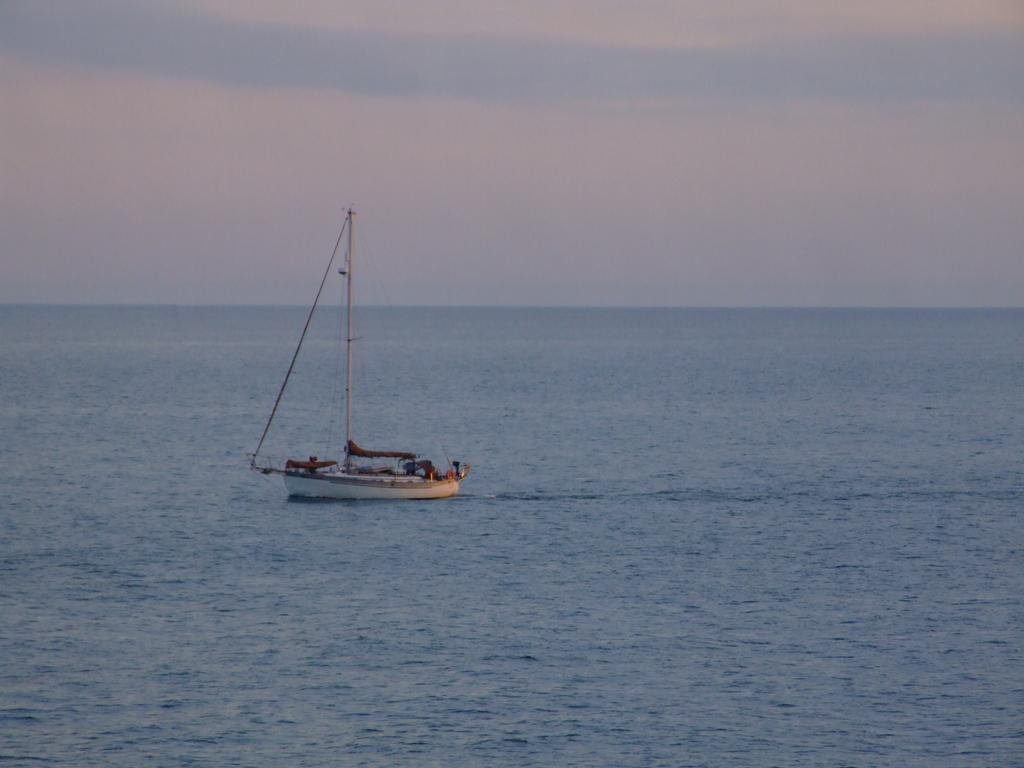What is the main subject in the center of the image? There is a boat in the center of the image. What can be seen in the background of the image? There is water visible in the background of the image. What is visible at the top of the image? The sky is visible at the top of the image. Where is the calendar located in the image? There is no calendar present in the image. What type of pan is being used to control the boat in the image? There is no pan or control mechanism for the boat visible in the image; it appears to be floating on the water. 